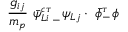Convert formula to latex. <formula><loc_0><loc_0><loc_500><loc_500>\frac { g _ { i j } } { m _ { p } } \ \bar { \psi } { ^ { c \tau } _ { L i } } _ { - } \psi _ { L j } \cdot \ \bar { \phi } _ { - } ^ { \tau } \phi</formula> 